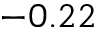Convert formula to latex. <formula><loc_0><loc_0><loc_500><loc_500>- 0 . 2 2</formula> 